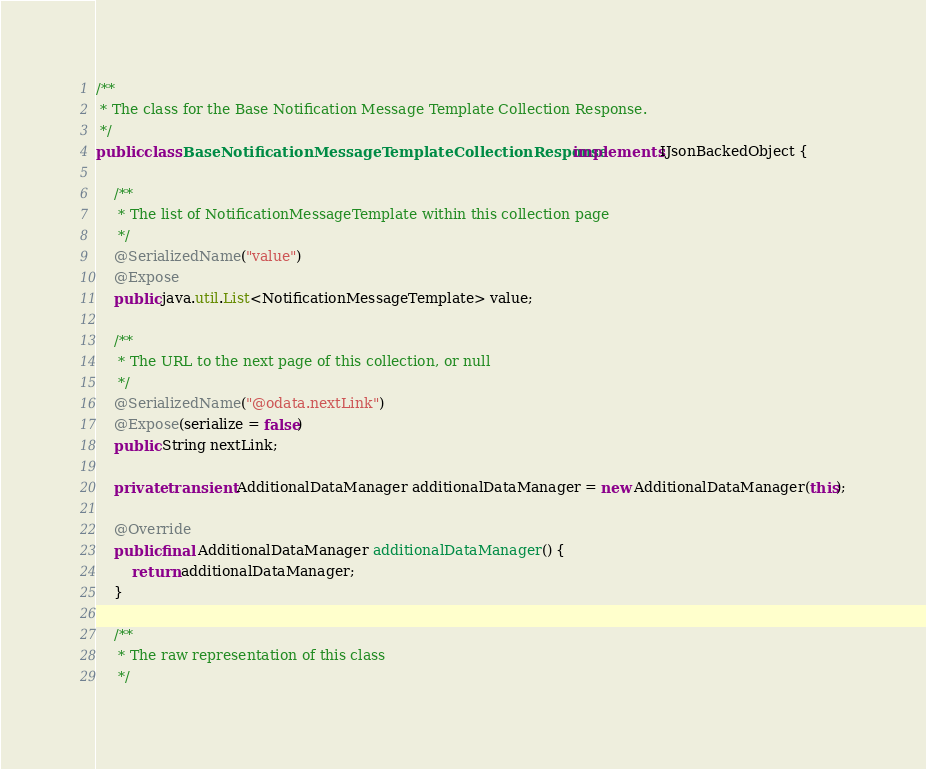Convert code to text. <code><loc_0><loc_0><loc_500><loc_500><_Java_>
/**
 * The class for the Base Notification Message Template Collection Response.
 */
public class BaseNotificationMessageTemplateCollectionResponse implements IJsonBackedObject {

    /**
     * The list of NotificationMessageTemplate within this collection page
     */
    @SerializedName("value")
    @Expose
    public java.util.List<NotificationMessageTemplate> value;

    /**
     * The URL to the next page of this collection, or null
     */
    @SerializedName("@odata.nextLink")
    @Expose(serialize = false)
    public String nextLink;

    private transient AdditionalDataManager additionalDataManager = new AdditionalDataManager(this);

    @Override
    public final AdditionalDataManager additionalDataManager() {
        return additionalDataManager;
    }

    /**
     * The raw representation of this class
     */</code> 